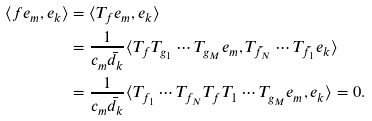<formula> <loc_0><loc_0><loc_500><loc_500>\langle f e _ { m } , e _ { k } \rangle & = \langle T _ { f } e _ { m } , e _ { k } \rangle \\ & = \frac { 1 } { c _ { m } \bar { d } _ { k } } \langle T _ { f } T _ { g _ { 1 } } \cdots T _ { g _ { M } } e _ { m } , T _ { \bar { f } _ { N } } \cdots T _ { \bar { f } _ { 1 } } e _ { k } \rangle \\ & = \frac { 1 } { c _ { m } \bar { d } _ { k } } \langle T _ { f _ { 1 } } \cdots T _ { f _ { N } } T _ { f } T _ { 1 } \cdots T _ { g _ { M } } e _ { m } , e _ { k } \rangle = 0 .</formula> 